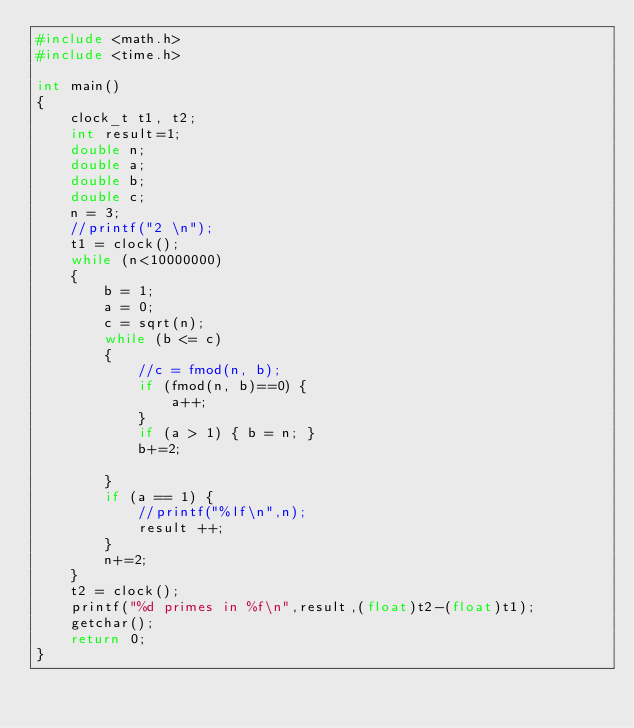Convert code to text. <code><loc_0><loc_0><loc_500><loc_500><_C_>#include <math.h>
#include <time.h>

int main()
{
    clock_t t1, t2;
    int result=1;
	double n;
	double a;
	double b;
	double c;
	n = 3;
	//printf("2 \n");
	t1 = clock();
	while (n<10000000)
	{
		b = 1;
		a = 0;
		c = sqrt(n);
		while (b <= c)
		{
			//c = fmod(n, b);
			if (fmod(n, b)==0) {
				a++;
			}
			if (a > 1) { b = n; }
			b+=2;

		}
		if (a == 1) {
			//printf("%lf\n",n);
			result ++;
		}
		n+=2;
	}
	t2 = clock();
	printf("%d primes in %f\n",result,(float)t2-(float)t1);
	getchar();
	return 0;
}
</code> 